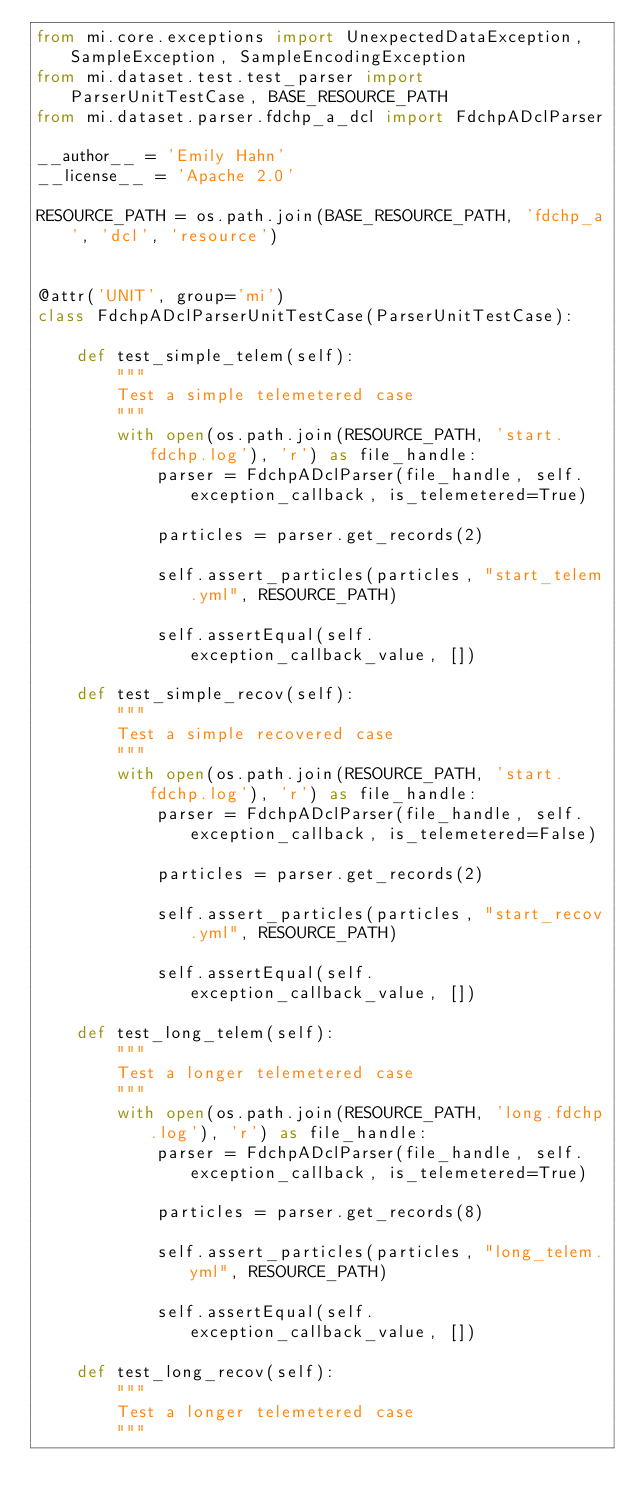<code> <loc_0><loc_0><loc_500><loc_500><_Python_>from mi.core.exceptions import UnexpectedDataException, SampleException, SampleEncodingException
from mi.dataset.test.test_parser import ParserUnitTestCase, BASE_RESOURCE_PATH
from mi.dataset.parser.fdchp_a_dcl import FdchpADclParser

__author__ = 'Emily Hahn'
__license__ = 'Apache 2.0'

RESOURCE_PATH = os.path.join(BASE_RESOURCE_PATH, 'fdchp_a', 'dcl', 'resource')


@attr('UNIT', group='mi')
class FdchpADclParserUnitTestCase(ParserUnitTestCase):

    def test_simple_telem(self):
        """
        Test a simple telemetered case
        """
        with open(os.path.join(RESOURCE_PATH, 'start.fdchp.log'), 'r') as file_handle:
            parser = FdchpADclParser(file_handle, self.exception_callback, is_telemetered=True)

            particles = parser.get_records(2)

            self.assert_particles(particles, "start_telem.yml", RESOURCE_PATH)

            self.assertEqual(self.exception_callback_value, [])

    def test_simple_recov(self):
        """
        Test a simple recovered case
        """
        with open(os.path.join(RESOURCE_PATH, 'start.fdchp.log'), 'r') as file_handle:
            parser = FdchpADclParser(file_handle, self.exception_callback, is_telemetered=False)

            particles = parser.get_records(2)

            self.assert_particles(particles, "start_recov.yml", RESOURCE_PATH)

            self.assertEqual(self.exception_callback_value, [])

    def test_long_telem(self):
        """
        Test a longer telemetered case
        """
        with open(os.path.join(RESOURCE_PATH, 'long.fdchp.log'), 'r') as file_handle:
            parser = FdchpADclParser(file_handle, self.exception_callback, is_telemetered=True)

            particles = parser.get_records(8)

            self.assert_particles(particles, "long_telem.yml", RESOURCE_PATH)

            self.assertEqual(self.exception_callback_value, [])

    def test_long_recov(self):
        """
        Test a longer telemetered case
        """</code> 